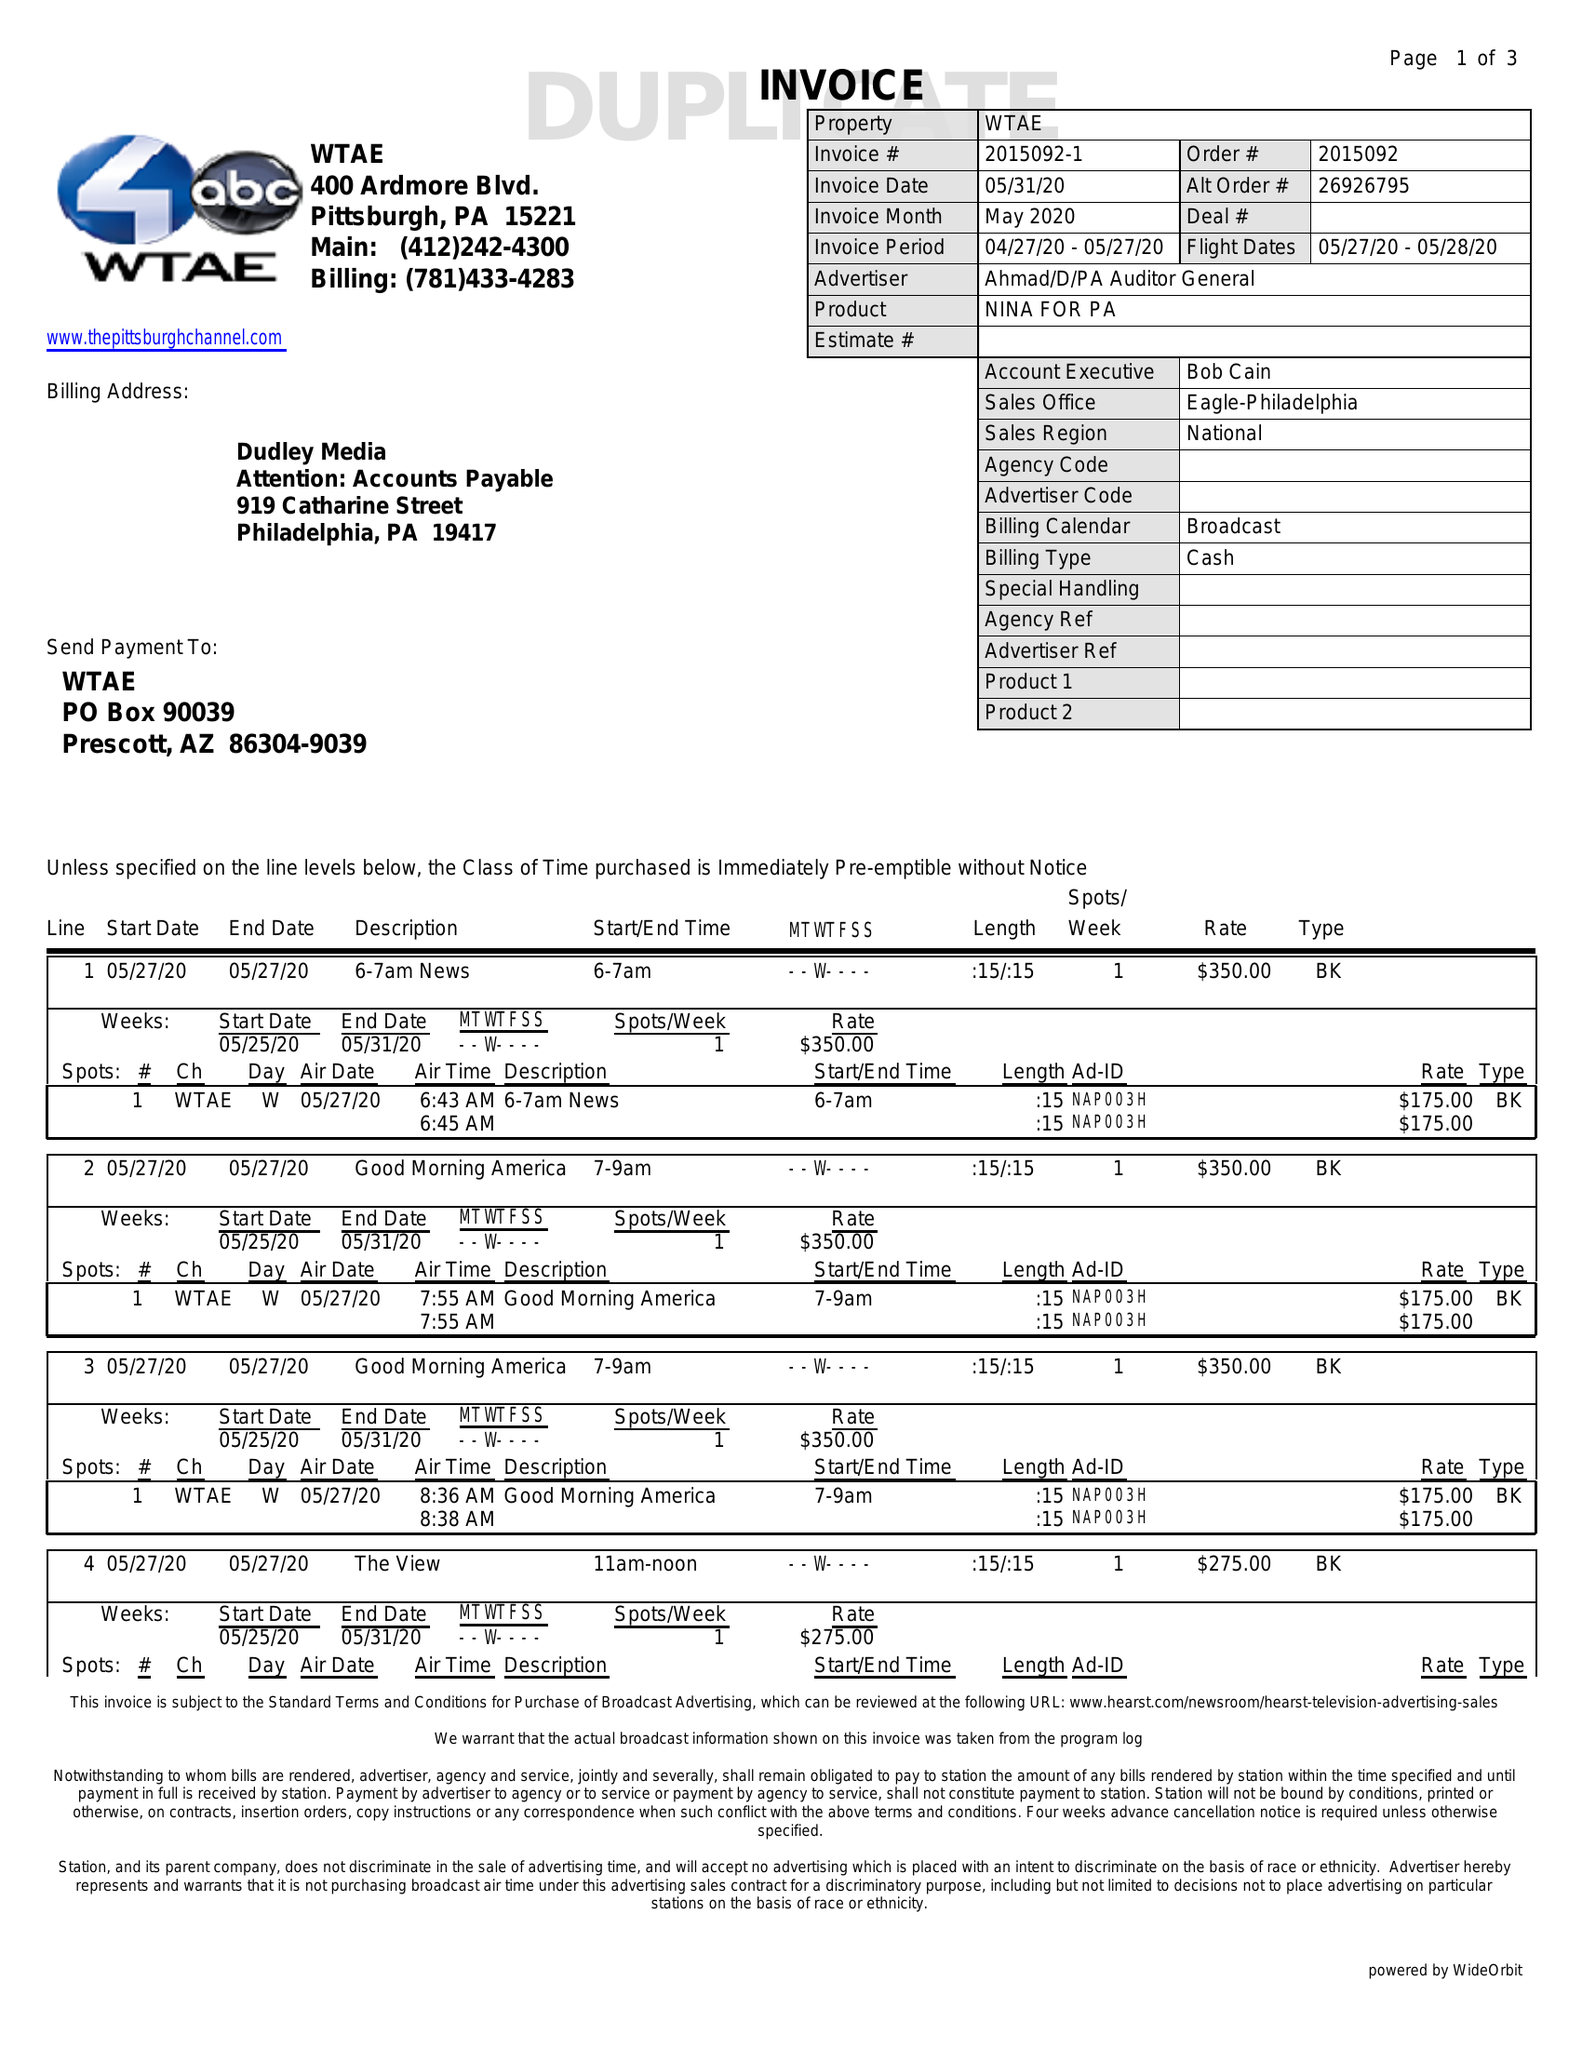What is the value for the flight_to?
Answer the question using a single word or phrase. 05/28/20 